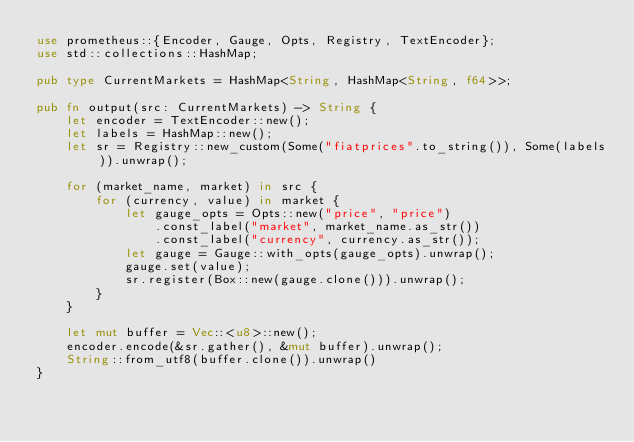<code> <loc_0><loc_0><loc_500><loc_500><_Rust_>use prometheus::{Encoder, Gauge, Opts, Registry, TextEncoder};
use std::collections::HashMap;

pub type CurrentMarkets = HashMap<String, HashMap<String, f64>>;

pub fn output(src: CurrentMarkets) -> String {
    let encoder = TextEncoder::new();
    let labels = HashMap::new();
    let sr = Registry::new_custom(Some("fiatprices".to_string()), Some(labels)).unwrap();

    for (market_name, market) in src {
        for (currency, value) in market {
            let gauge_opts = Opts::new("price", "price")
                .const_label("market", market_name.as_str())
                .const_label("currency", currency.as_str());
            let gauge = Gauge::with_opts(gauge_opts).unwrap();
            gauge.set(value);
            sr.register(Box::new(gauge.clone())).unwrap();
        }
    }

    let mut buffer = Vec::<u8>::new();
    encoder.encode(&sr.gather(), &mut buffer).unwrap();
    String::from_utf8(buffer.clone()).unwrap()
}
</code> 